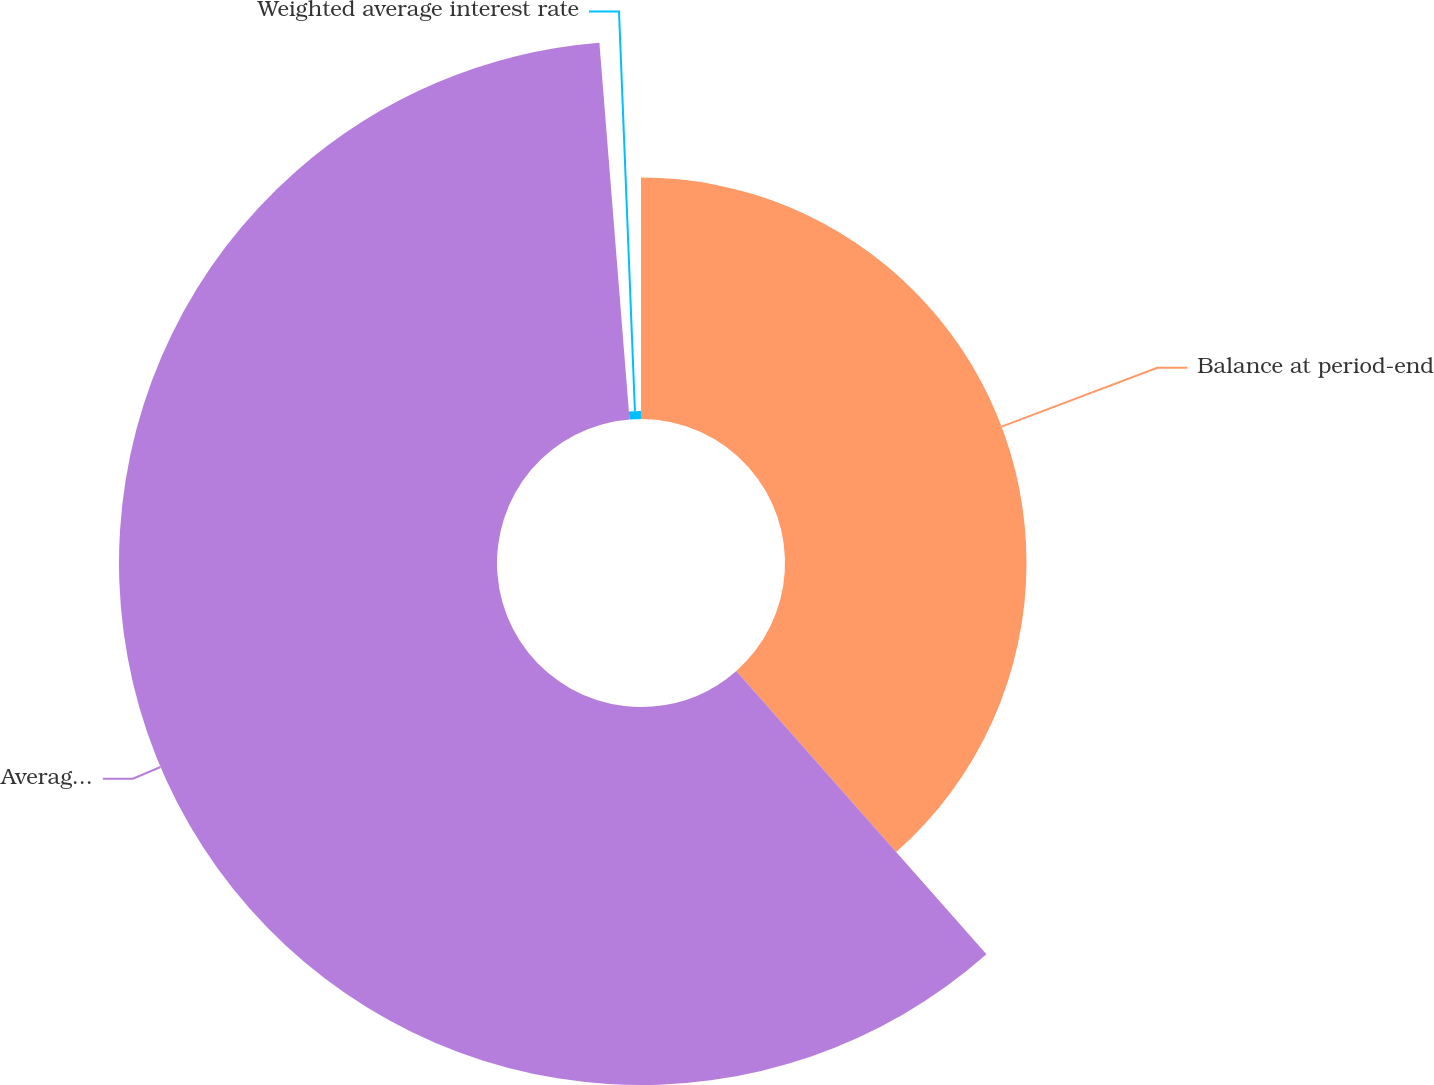Convert chart. <chart><loc_0><loc_0><loc_500><loc_500><pie_chart><fcel>Balance at period-end<fcel>Average balance(2)<fcel>Weighted average interest rate<nl><fcel>38.49%<fcel>60.24%<fcel>1.27%<nl></chart> 